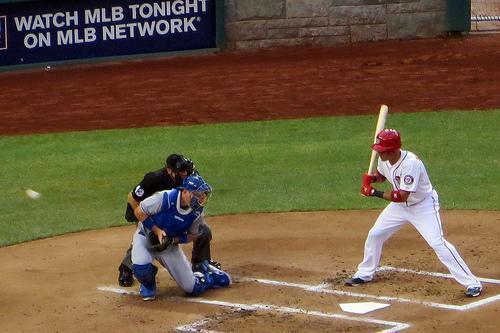How many players on the field?
Give a very brief answer. 3. 